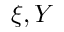Convert formula to latex. <formula><loc_0><loc_0><loc_500><loc_500>\xi , Y</formula> 